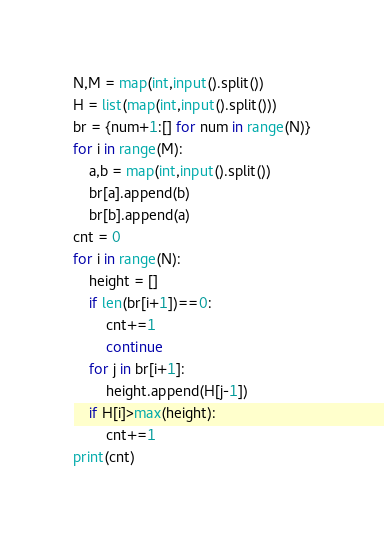<code> <loc_0><loc_0><loc_500><loc_500><_Python_>N,M = map(int,input().split())
H = list(map(int,input().split()))
br = {num+1:[] for num in range(N)}
for i in range(M):
    a,b = map(int,input().split())
    br[a].append(b)
    br[b].append(a)
cnt = 0
for i in range(N):
    height = []
    if len(br[i+1])==0:
        cnt+=1
        continue
    for j in br[i+1]:
        height.append(H[j-1])
    if H[i]>max(height):
        cnt+=1
print(cnt)</code> 